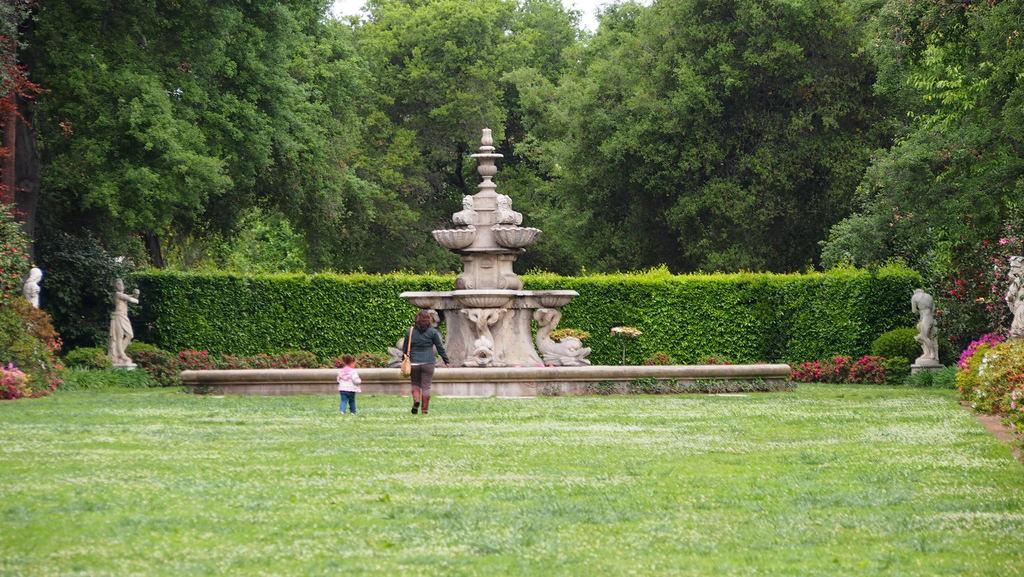Please provide a concise description of this image. In the center of the image there is a fountain. There are people walking on the grass. In the background of the image there are trees. there are statues to the both sides of the image. There are plants. 